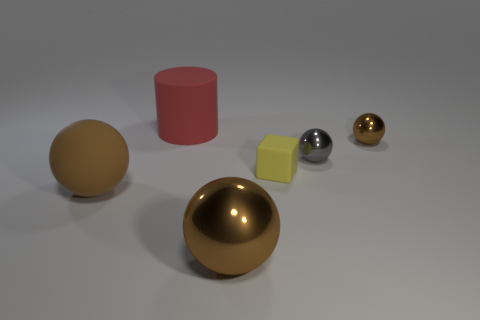Subtract all yellow cubes. How many brown spheres are left? 3 Add 1 brown matte objects. How many objects exist? 7 Subtract all spheres. How many objects are left? 2 Add 4 tiny matte things. How many tiny matte things exist? 5 Subtract 0 cyan blocks. How many objects are left? 6 Subtract all large brown metallic spheres. Subtract all yellow things. How many objects are left? 4 Add 1 large metallic objects. How many large metallic objects are left? 2 